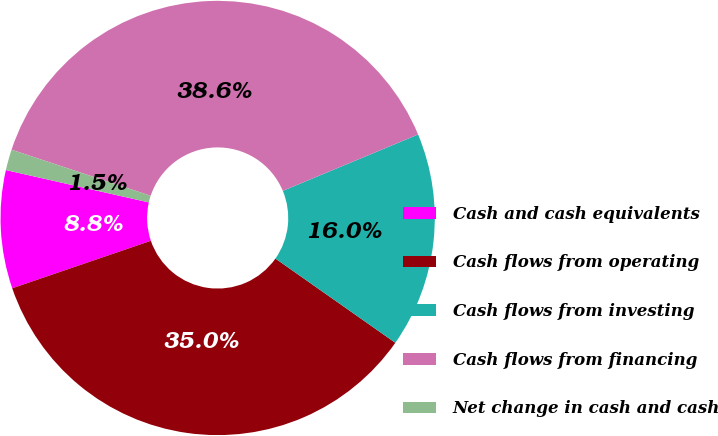Convert chart to OTSL. <chart><loc_0><loc_0><loc_500><loc_500><pie_chart><fcel>Cash and cash equivalents<fcel>Cash flows from operating<fcel>Cash flows from investing<fcel>Cash flows from financing<fcel>Net change in cash and cash<nl><fcel>8.79%<fcel>35.01%<fcel>16.03%<fcel>38.63%<fcel>1.55%<nl></chart> 